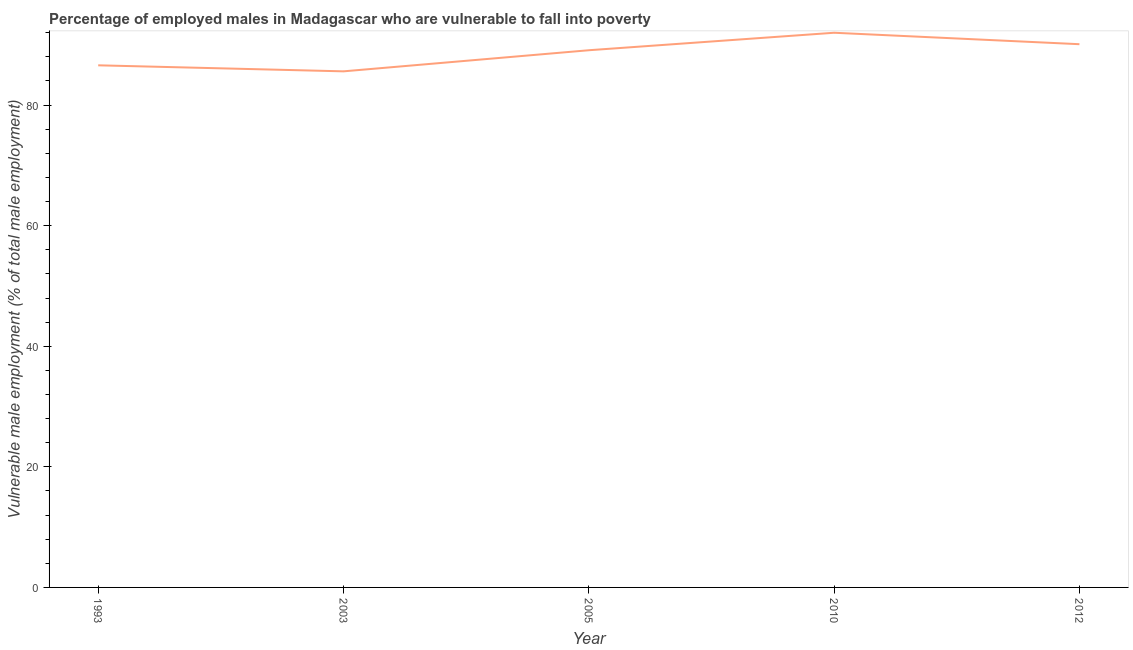What is the percentage of employed males who are vulnerable to fall into poverty in 2005?
Offer a terse response. 89.1. Across all years, what is the maximum percentage of employed males who are vulnerable to fall into poverty?
Give a very brief answer. 92. Across all years, what is the minimum percentage of employed males who are vulnerable to fall into poverty?
Give a very brief answer. 85.6. In which year was the percentage of employed males who are vulnerable to fall into poverty maximum?
Offer a very short reply. 2010. What is the sum of the percentage of employed males who are vulnerable to fall into poverty?
Keep it short and to the point. 443.4. What is the average percentage of employed males who are vulnerable to fall into poverty per year?
Offer a very short reply. 88.68. What is the median percentage of employed males who are vulnerable to fall into poverty?
Ensure brevity in your answer.  89.1. Do a majority of the years between 1993 and 2005 (inclusive) have percentage of employed males who are vulnerable to fall into poverty greater than 44 %?
Offer a terse response. Yes. What is the ratio of the percentage of employed males who are vulnerable to fall into poverty in 2003 to that in 2010?
Provide a short and direct response. 0.93. Is the percentage of employed males who are vulnerable to fall into poverty in 2005 less than that in 2010?
Your answer should be very brief. Yes. Is the difference between the percentage of employed males who are vulnerable to fall into poverty in 1993 and 2010 greater than the difference between any two years?
Your answer should be very brief. No. What is the difference between the highest and the second highest percentage of employed males who are vulnerable to fall into poverty?
Keep it short and to the point. 1.9. What is the difference between the highest and the lowest percentage of employed males who are vulnerable to fall into poverty?
Give a very brief answer. 6.4. In how many years, is the percentage of employed males who are vulnerable to fall into poverty greater than the average percentage of employed males who are vulnerable to fall into poverty taken over all years?
Keep it short and to the point. 3. How many years are there in the graph?
Keep it short and to the point. 5. What is the title of the graph?
Give a very brief answer. Percentage of employed males in Madagascar who are vulnerable to fall into poverty. What is the label or title of the Y-axis?
Offer a very short reply. Vulnerable male employment (% of total male employment). What is the Vulnerable male employment (% of total male employment) in 1993?
Keep it short and to the point. 86.6. What is the Vulnerable male employment (% of total male employment) of 2003?
Keep it short and to the point. 85.6. What is the Vulnerable male employment (% of total male employment) in 2005?
Provide a succinct answer. 89.1. What is the Vulnerable male employment (% of total male employment) in 2010?
Your answer should be very brief. 92. What is the Vulnerable male employment (% of total male employment) in 2012?
Offer a very short reply. 90.1. What is the difference between the Vulnerable male employment (% of total male employment) in 1993 and 2012?
Offer a terse response. -3.5. What is the difference between the Vulnerable male employment (% of total male employment) in 2003 and 2005?
Provide a succinct answer. -3.5. What is the difference between the Vulnerable male employment (% of total male employment) in 2003 and 2010?
Your answer should be very brief. -6.4. What is the difference between the Vulnerable male employment (% of total male employment) in 2010 and 2012?
Make the answer very short. 1.9. What is the ratio of the Vulnerable male employment (% of total male employment) in 1993 to that in 2005?
Ensure brevity in your answer.  0.97. What is the ratio of the Vulnerable male employment (% of total male employment) in 1993 to that in 2010?
Give a very brief answer. 0.94. What is the ratio of the Vulnerable male employment (% of total male employment) in 1993 to that in 2012?
Make the answer very short. 0.96. 